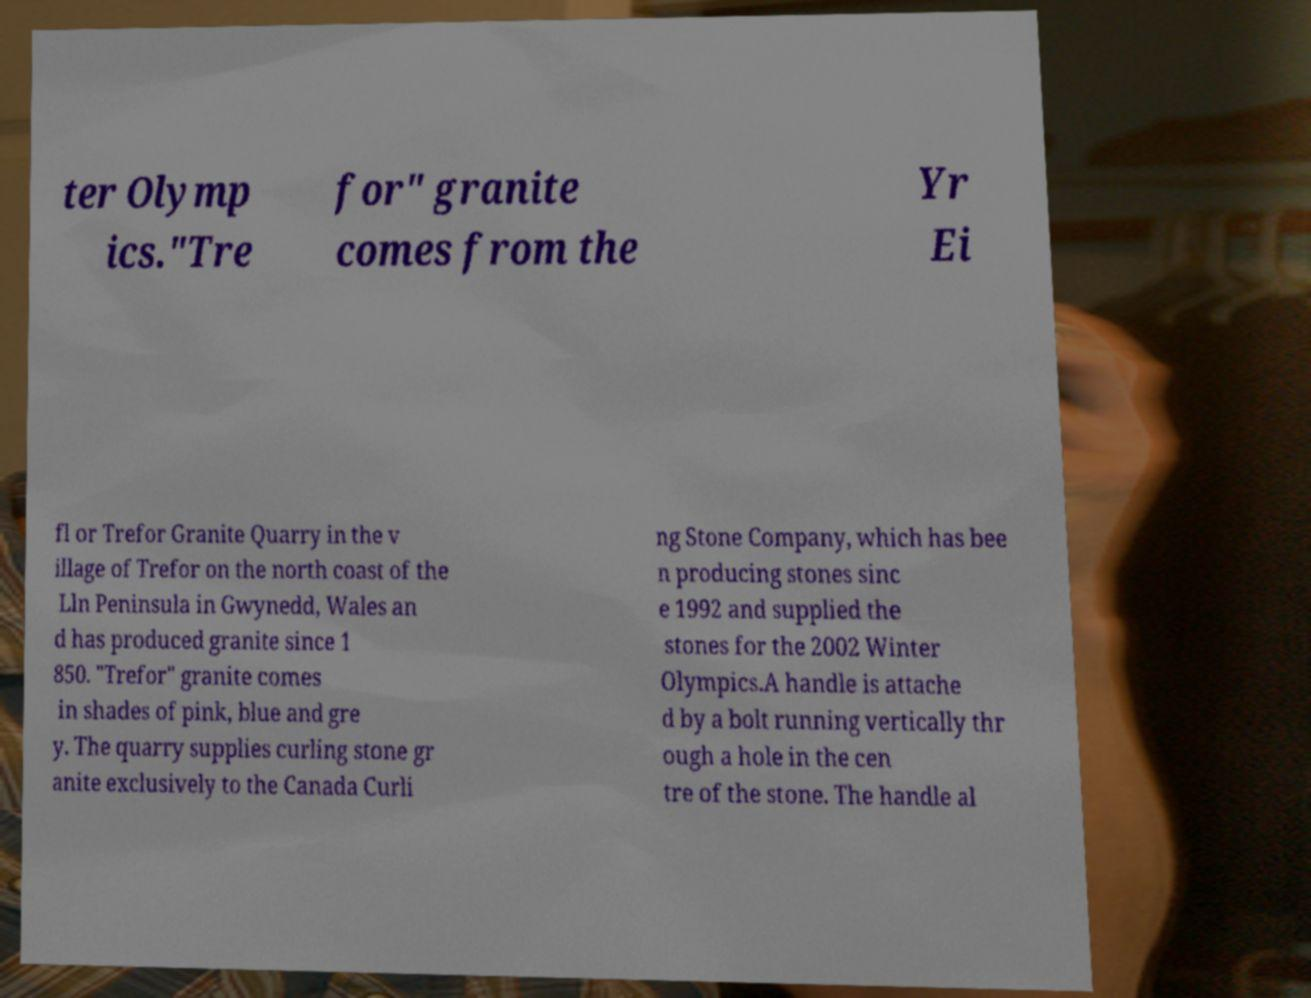Please identify and transcribe the text found in this image. ter Olymp ics."Tre for" granite comes from the Yr Ei fl or Trefor Granite Quarry in the v illage of Trefor on the north coast of the Lln Peninsula in Gwynedd, Wales an d has produced granite since 1 850. "Trefor" granite comes in shades of pink, blue and gre y. The quarry supplies curling stone gr anite exclusively to the Canada Curli ng Stone Company, which has bee n producing stones sinc e 1992 and supplied the stones for the 2002 Winter Olympics.A handle is attache d by a bolt running vertically thr ough a hole in the cen tre of the stone. The handle al 